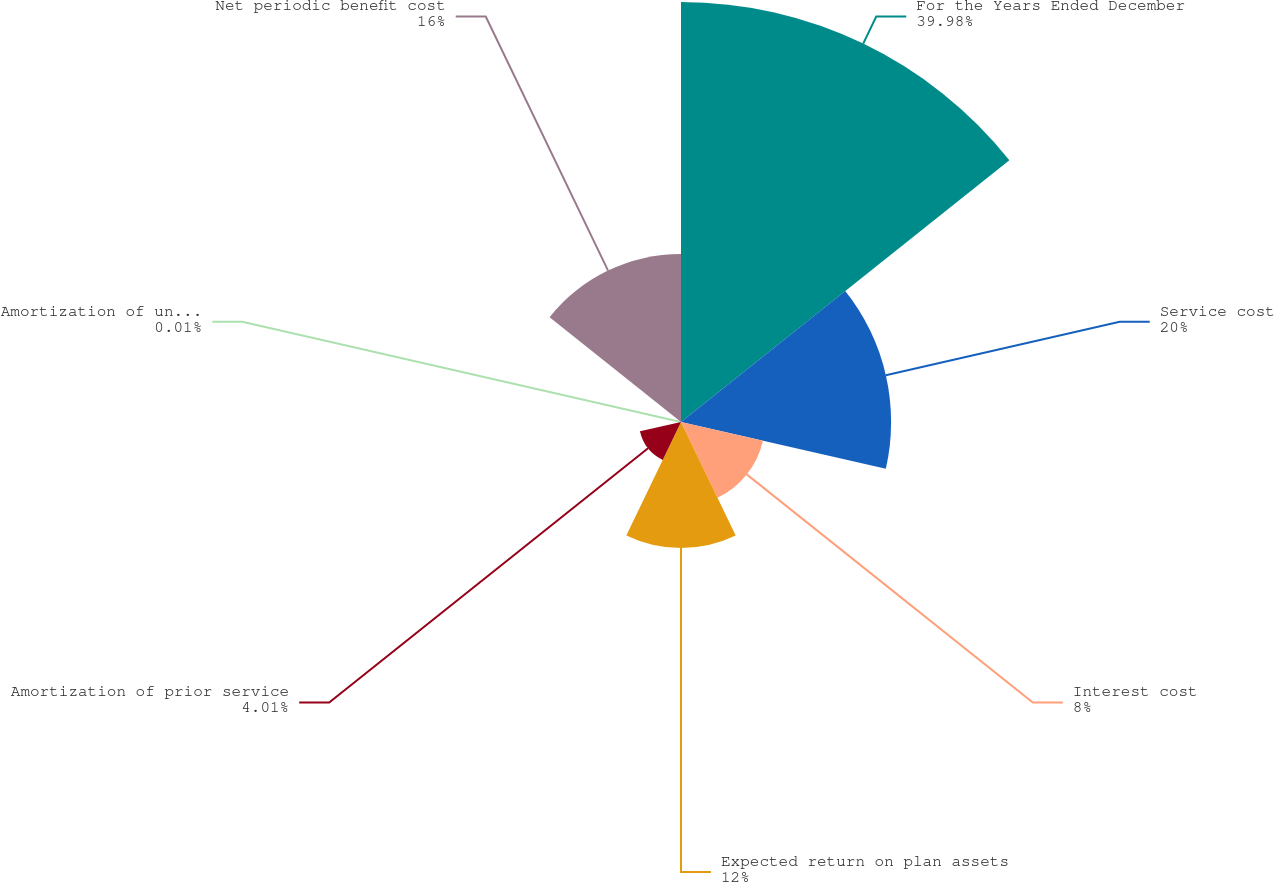<chart> <loc_0><loc_0><loc_500><loc_500><pie_chart><fcel>For the Years Ended December<fcel>Service cost<fcel>Interest cost<fcel>Expected return on plan assets<fcel>Amortization of prior service<fcel>Amortization of unrecognized<fcel>Net periodic benefit cost<nl><fcel>39.98%<fcel>20.0%<fcel>8.0%<fcel>12.0%<fcel>4.01%<fcel>0.01%<fcel>16.0%<nl></chart> 